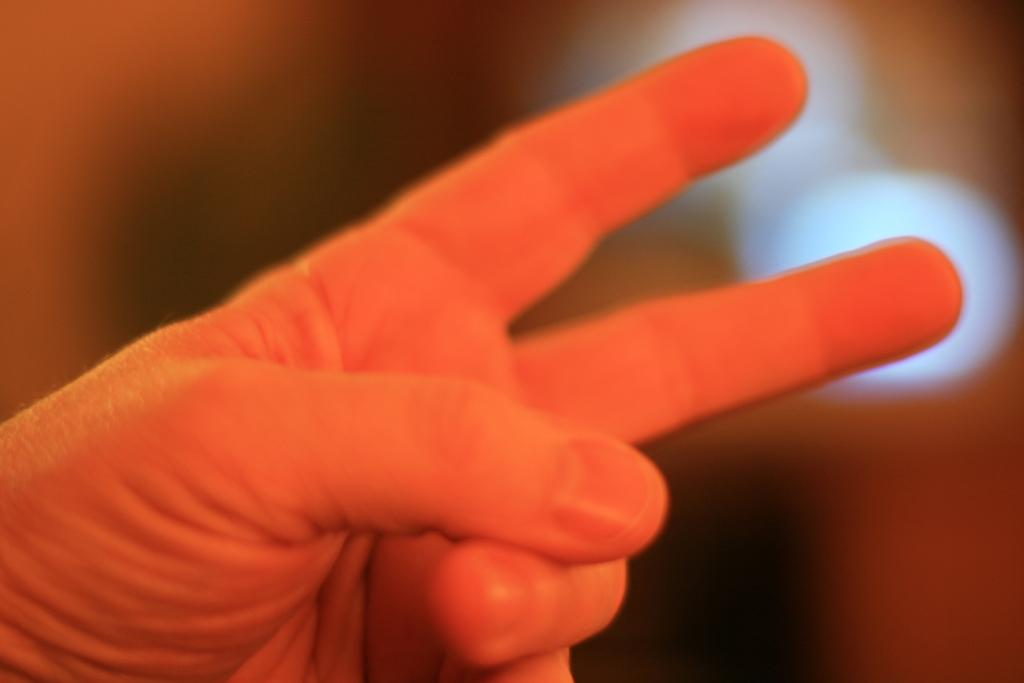What part of a person's body is visible in the image? There is a person's hand in the image. Can you describe the fingers in the image? The person's fingers are visible in the image. What can be observed about the background of the image? The background of the image is blurred. What type of popcorn is being served by the servant in the image? There is no popcorn or servant present in the image. What is the mass of the object being held by the person in the image? There is no object being held by a person in the image, so it is not possible to determine its mass. 